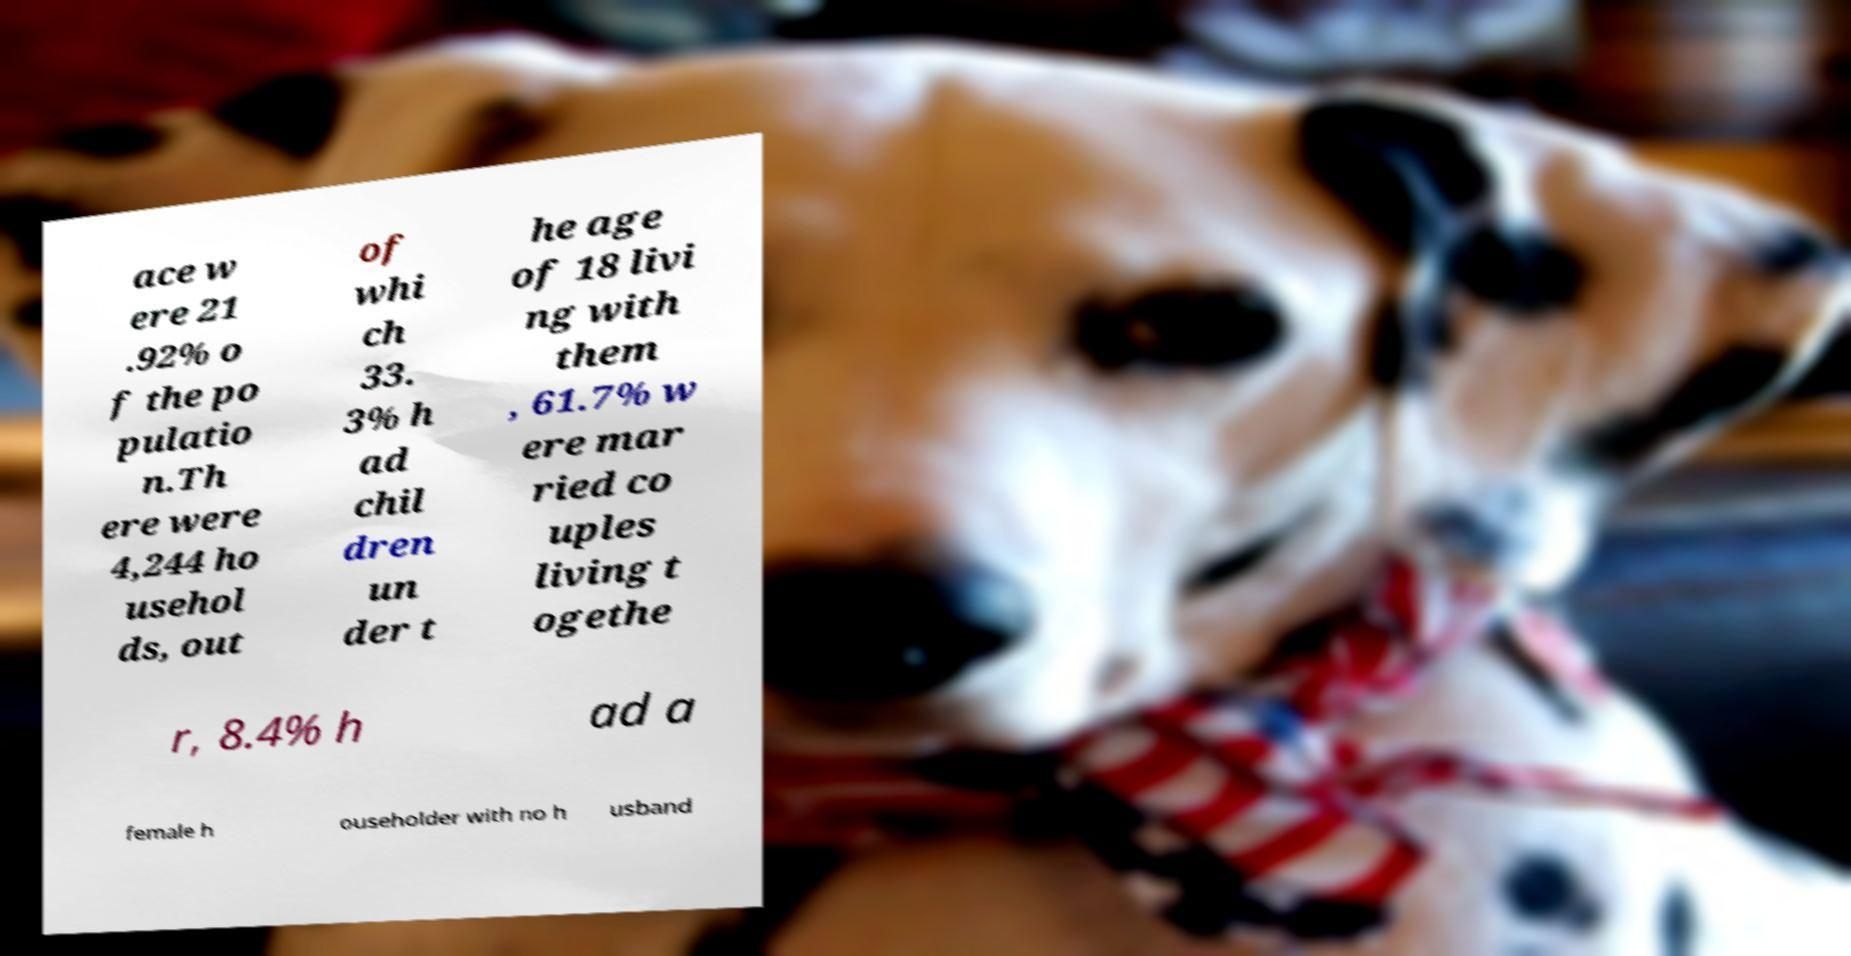What messages or text are displayed in this image? I need them in a readable, typed format. ace w ere 21 .92% o f the po pulatio n.Th ere were 4,244 ho usehol ds, out of whi ch 33. 3% h ad chil dren un der t he age of 18 livi ng with them , 61.7% w ere mar ried co uples living t ogethe r, 8.4% h ad a female h ouseholder with no h usband 